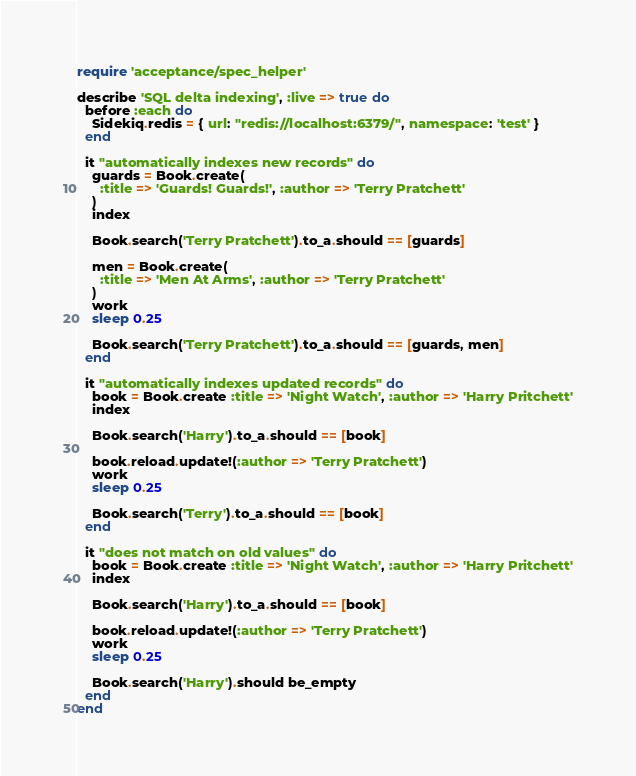Convert code to text. <code><loc_0><loc_0><loc_500><loc_500><_Ruby_>require 'acceptance/spec_helper'

describe 'SQL delta indexing', :live => true do
  before :each do
    Sidekiq.redis = { url: "redis://localhost:6379/", namespace: 'test' }
  end

  it "automatically indexes new records" do
    guards = Book.create(
      :title => 'Guards! Guards!', :author => 'Terry Pratchett'
    )
    index

    Book.search('Terry Pratchett').to_a.should == [guards]

    men = Book.create(
      :title => 'Men At Arms', :author => 'Terry Pratchett'
    )
    work
    sleep 0.25

    Book.search('Terry Pratchett').to_a.should == [guards, men]
  end

  it "automatically indexes updated records" do
    book = Book.create :title => 'Night Watch', :author => 'Harry Pritchett'
    index

    Book.search('Harry').to_a.should == [book]

    book.reload.update!(:author => 'Terry Pratchett')
    work
    sleep 0.25

    Book.search('Terry').to_a.should == [book]
  end

  it "does not match on old values" do
    book = Book.create :title => 'Night Watch', :author => 'Harry Pritchett'
    index

    Book.search('Harry').to_a.should == [book]

    book.reload.update!(:author => 'Terry Pratchett')
    work
    sleep 0.25

    Book.search('Harry').should be_empty
  end
end
</code> 